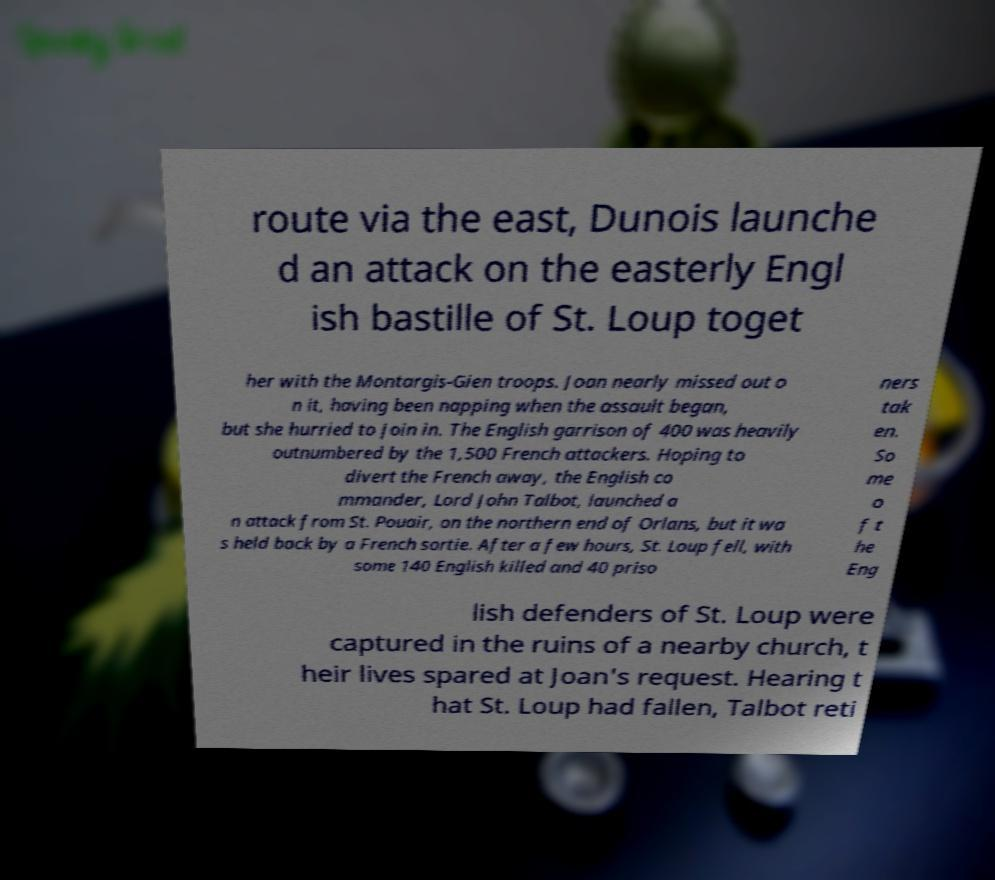There's text embedded in this image that I need extracted. Can you transcribe it verbatim? route via the east, Dunois launche d an attack on the easterly Engl ish bastille of St. Loup toget her with the Montargis-Gien troops. Joan nearly missed out o n it, having been napping when the assault began, but she hurried to join in. The English garrison of 400 was heavily outnumbered by the 1,500 French attackers. Hoping to divert the French away, the English co mmander, Lord John Talbot, launched a n attack from St. Pouair, on the northern end of Orlans, but it wa s held back by a French sortie. After a few hours, St. Loup fell, with some 140 English killed and 40 priso ners tak en. So me o f t he Eng lish defenders of St. Loup were captured in the ruins of a nearby church, t heir lives spared at Joan's request. Hearing t hat St. Loup had fallen, Talbot reti 